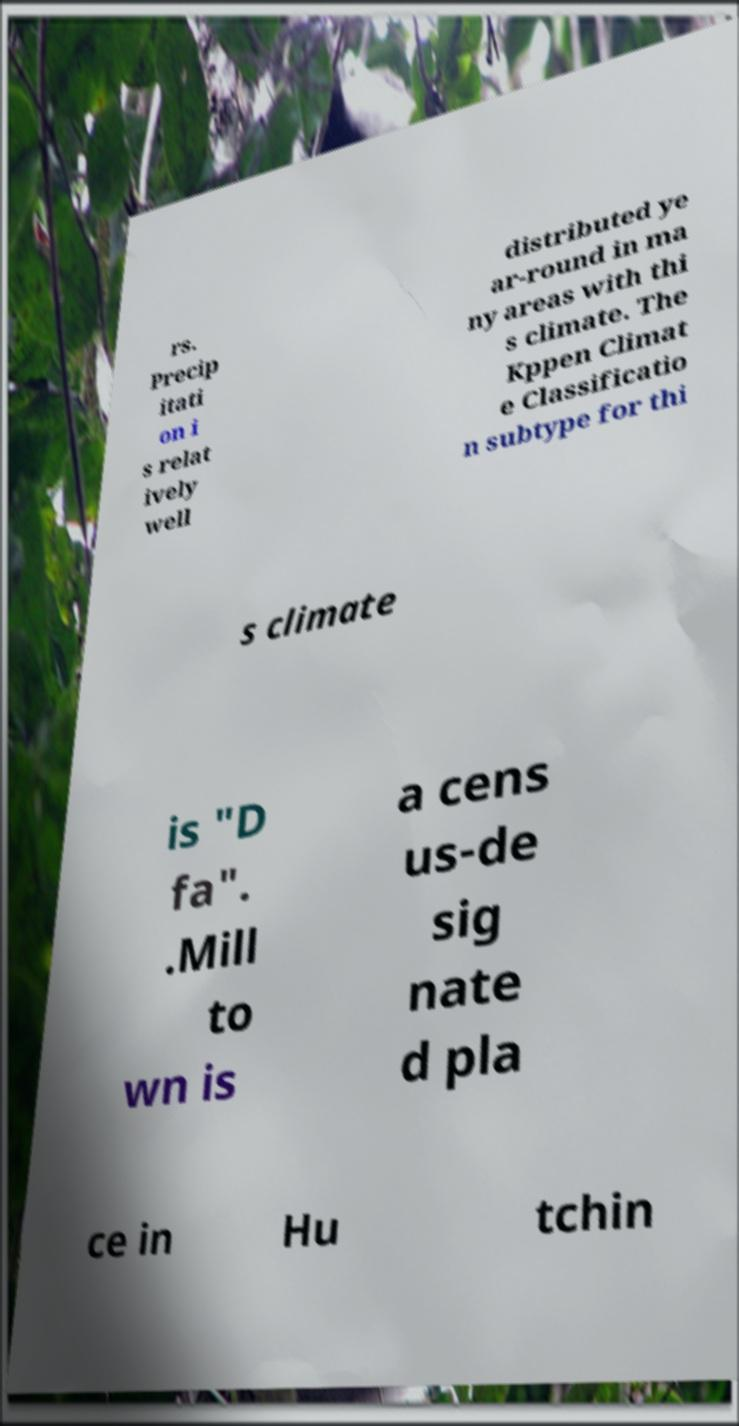Can you read and provide the text displayed in the image?This photo seems to have some interesting text. Can you extract and type it out for me? rs. Precip itati on i s relat ively well distributed ye ar-round in ma ny areas with thi s climate. The Kppen Climat e Classificatio n subtype for thi s climate is "D fa". .Mill to wn is a cens us-de sig nate d pla ce in Hu tchin 